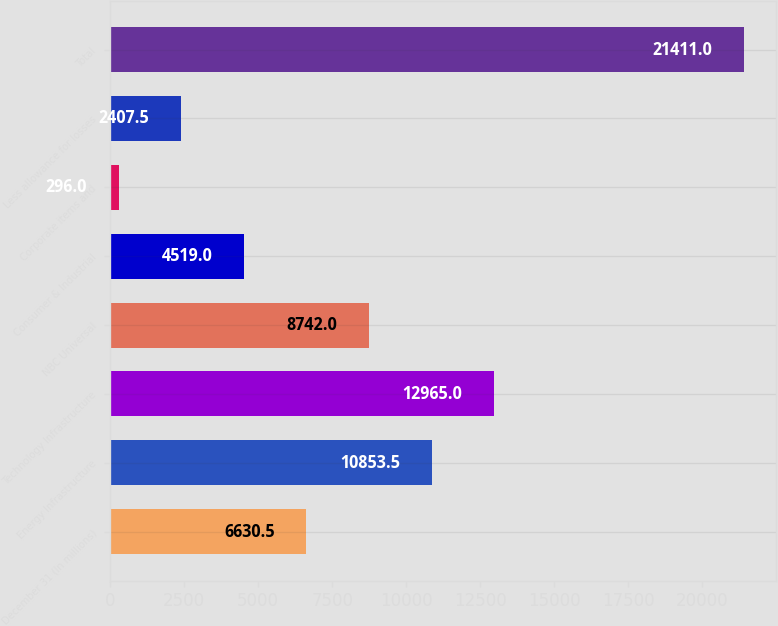Convert chart. <chart><loc_0><loc_0><loc_500><loc_500><bar_chart><fcel>December 31 (In millions)<fcel>Energy Infrastructure<fcel>Technology Infrastructure<fcel>NBC Universal<fcel>Consumer & Industrial<fcel>Corporate items and<fcel>Less allowance for losses<fcel>Total<nl><fcel>6630.5<fcel>10853.5<fcel>12965<fcel>8742<fcel>4519<fcel>296<fcel>2407.5<fcel>21411<nl></chart> 